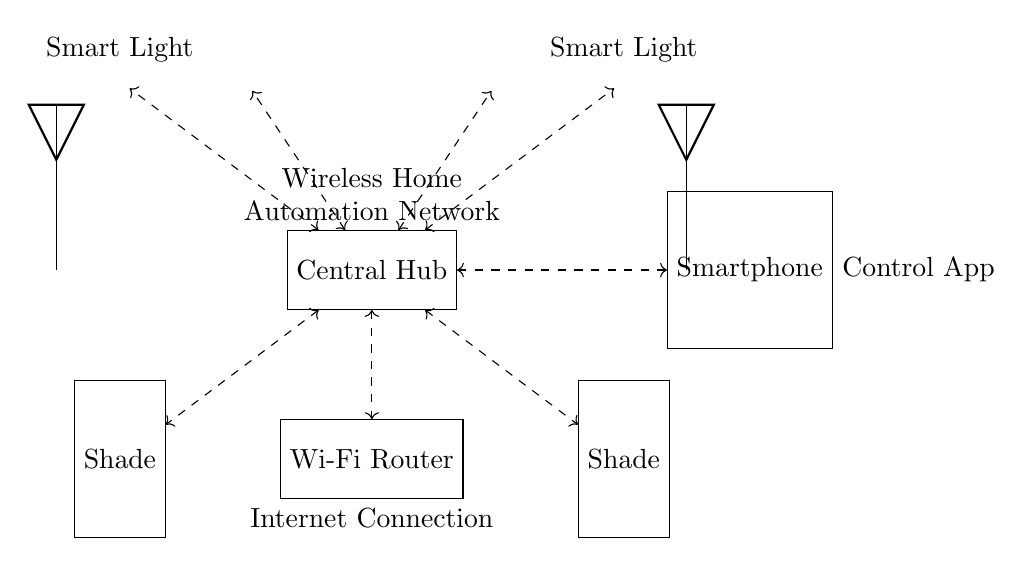What is the central component in this circuit? The central component is labeled as the "Central Hub", which connects various devices in the wireless network.
Answer: Central Hub How many smart light bulbs are connected to the hub? There are four smart light bulbs shown in the circuit diagram, all connected to the hub.
Answer: Four What devices are controlled by the Central Hub? The devices connected to the Central Hub include smart light bulbs and window shades, as indicated by the connections.
Answer: Smart light bulbs and window shades What is the primary connection between the hub and the Wi-Fi router? The primary connection is a dashed double-headed arrow, indicating a wireless connection between the hub and the Wi-Fi router.
Answer: Wireless connection What type of connection does the smartphone have with the Central Hub? The smartphone has a wireless connection to the Central Hub, just like the other devices, represented by a dashed line.
Answer: Wireless connection How does the Central Hub communicate with the smart devices? The Central Hub communicates with the smart devices via wireless signals, which are illustrated with dashed lines between the hub and the devices.
Answer: Wireless signals What function does the smartphone serve in this network? The smartphone functions as a control app, providing a user interface to manage the smart lighting and window shades.
Answer: Control app 